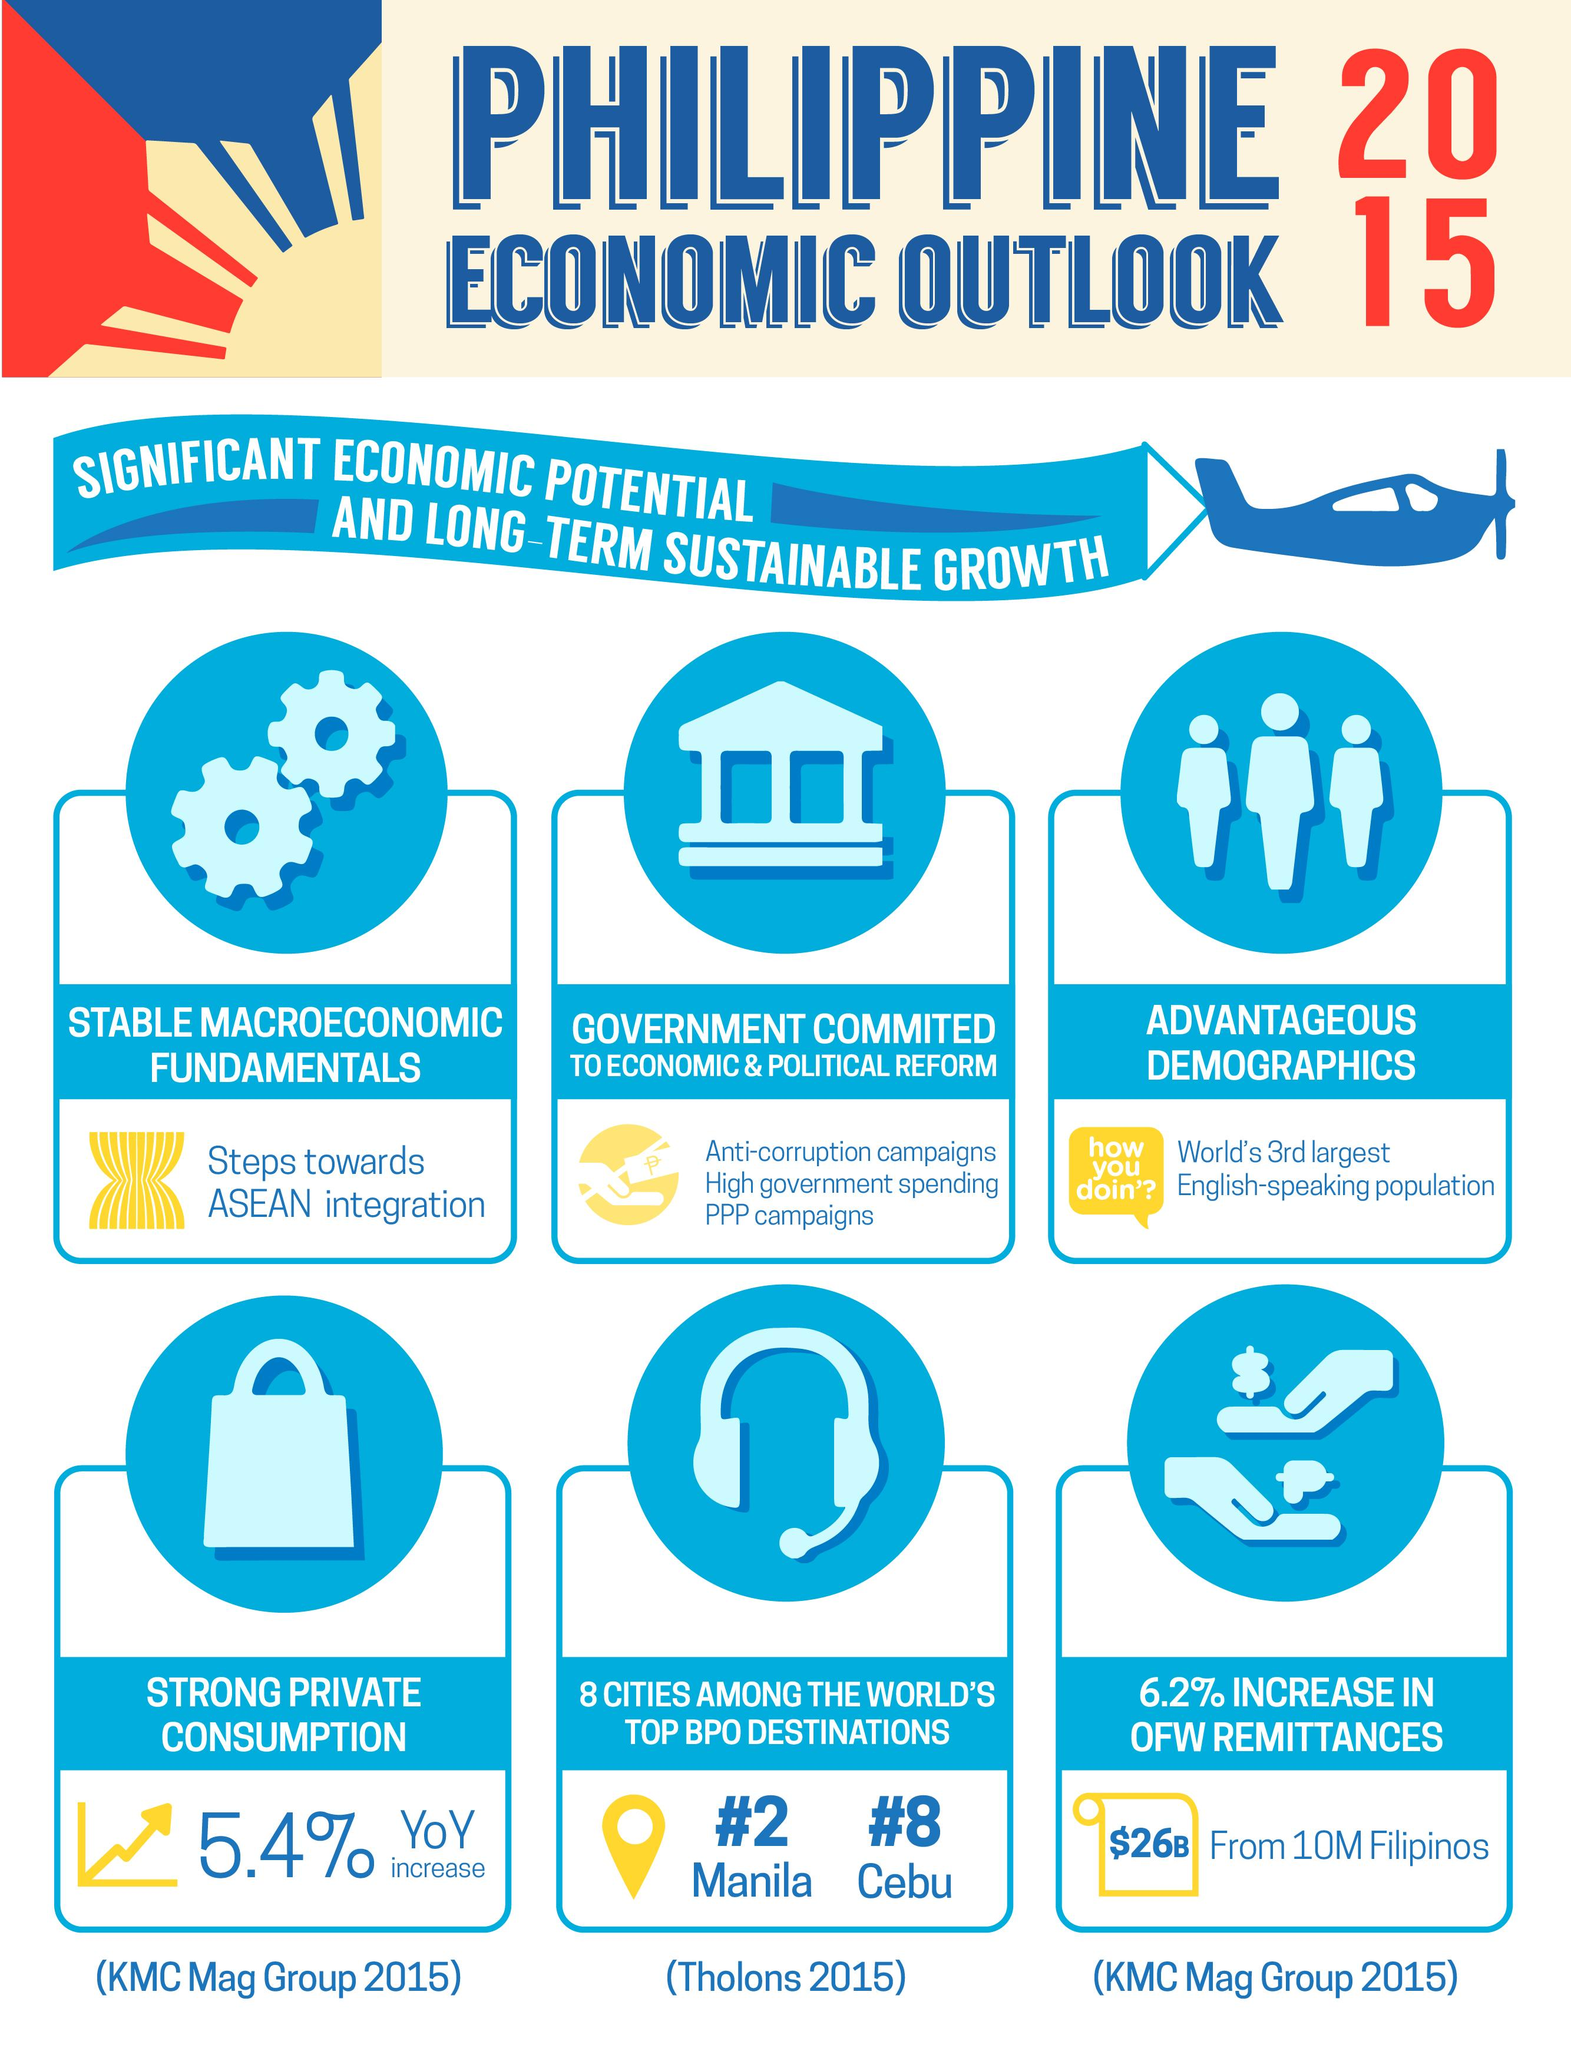Give some essential details in this illustration. The infographic contains 6 points about the Philippines' economy. The third point highlighted in the infographic about the Philippines' economy is its advantageous demographics, which provide a significant advantage for the country's economic growth. The infographic contains three icons depicting people. This infographic contains one airplane icon. This infographic contains two hands. 